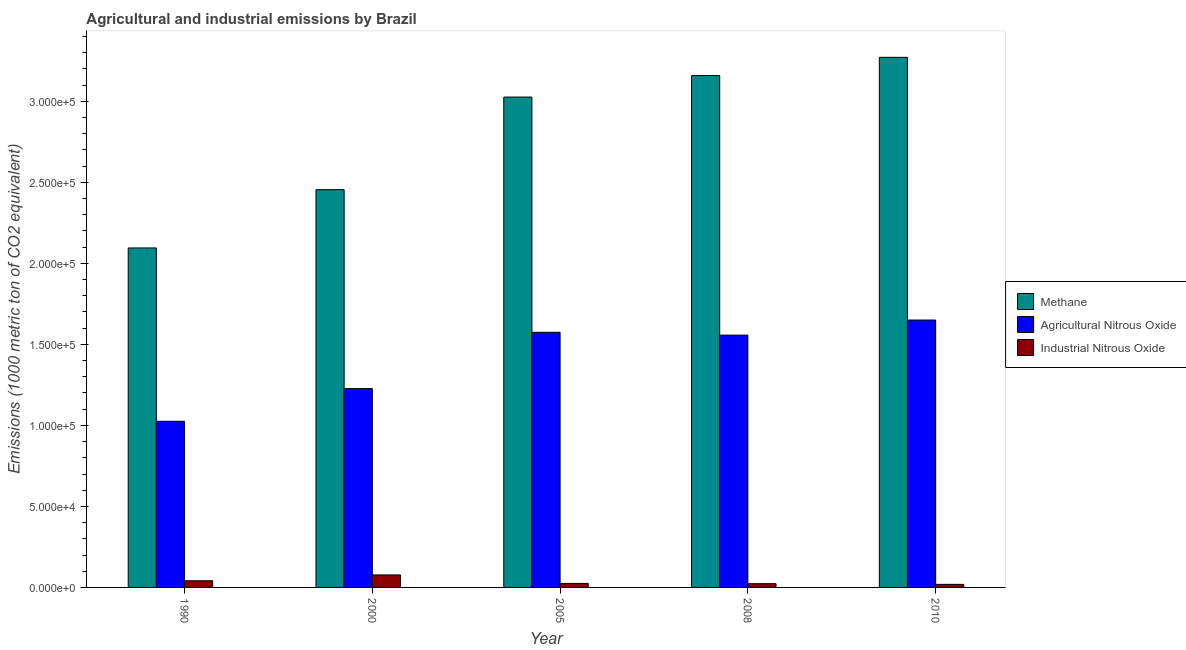How many groups of bars are there?
Your answer should be compact. 5. Are the number of bars per tick equal to the number of legend labels?
Your answer should be compact. Yes. Are the number of bars on each tick of the X-axis equal?
Provide a succinct answer. Yes. How many bars are there on the 1st tick from the right?
Offer a terse response. 3. What is the label of the 2nd group of bars from the left?
Offer a very short reply. 2000. What is the amount of agricultural nitrous oxide emissions in 2005?
Provide a succinct answer. 1.57e+05. Across all years, what is the maximum amount of methane emissions?
Your answer should be compact. 3.27e+05. Across all years, what is the minimum amount of agricultural nitrous oxide emissions?
Keep it short and to the point. 1.03e+05. In which year was the amount of agricultural nitrous oxide emissions maximum?
Keep it short and to the point. 2010. In which year was the amount of agricultural nitrous oxide emissions minimum?
Make the answer very short. 1990. What is the total amount of agricultural nitrous oxide emissions in the graph?
Provide a succinct answer. 7.03e+05. What is the difference between the amount of agricultural nitrous oxide emissions in 2005 and that in 2008?
Your response must be concise. 1744.8. What is the difference between the amount of industrial nitrous oxide emissions in 2005 and the amount of agricultural nitrous oxide emissions in 1990?
Keep it short and to the point. -1632.9. What is the average amount of agricultural nitrous oxide emissions per year?
Your answer should be compact. 1.41e+05. In how many years, is the amount of agricultural nitrous oxide emissions greater than 290000 metric ton?
Your response must be concise. 0. What is the ratio of the amount of industrial nitrous oxide emissions in 1990 to that in 2005?
Offer a terse response. 1.66. Is the amount of agricultural nitrous oxide emissions in 2005 less than that in 2010?
Offer a very short reply. Yes. What is the difference between the highest and the second highest amount of agricultural nitrous oxide emissions?
Provide a short and direct response. 7569.5. What is the difference between the highest and the lowest amount of methane emissions?
Provide a short and direct response. 1.18e+05. What does the 3rd bar from the left in 2005 represents?
Your response must be concise. Industrial Nitrous Oxide. What does the 2nd bar from the right in 2000 represents?
Provide a succinct answer. Agricultural Nitrous Oxide. How many years are there in the graph?
Make the answer very short. 5. Does the graph contain any zero values?
Keep it short and to the point. No. Does the graph contain grids?
Ensure brevity in your answer.  No. Where does the legend appear in the graph?
Keep it short and to the point. Center right. What is the title of the graph?
Provide a succinct answer. Agricultural and industrial emissions by Brazil. What is the label or title of the Y-axis?
Offer a terse response. Emissions (1000 metric ton of CO2 equivalent). What is the Emissions (1000 metric ton of CO2 equivalent) of Methane in 1990?
Provide a short and direct response. 2.10e+05. What is the Emissions (1000 metric ton of CO2 equivalent) in Agricultural Nitrous Oxide in 1990?
Offer a very short reply. 1.03e+05. What is the Emissions (1000 metric ton of CO2 equivalent) in Industrial Nitrous Oxide in 1990?
Your answer should be very brief. 4111.4. What is the Emissions (1000 metric ton of CO2 equivalent) of Methane in 2000?
Offer a very short reply. 2.45e+05. What is the Emissions (1000 metric ton of CO2 equivalent) of Agricultural Nitrous Oxide in 2000?
Make the answer very short. 1.23e+05. What is the Emissions (1000 metric ton of CO2 equivalent) in Industrial Nitrous Oxide in 2000?
Offer a terse response. 7709.7. What is the Emissions (1000 metric ton of CO2 equivalent) of Methane in 2005?
Keep it short and to the point. 3.03e+05. What is the Emissions (1000 metric ton of CO2 equivalent) of Agricultural Nitrous Oxide in 2005?
Your answer should be compact. 1.57e+05. What is the Emissions (1000 metric ton of CO2 equivalent) in Industrial Nitrous Oxide in 2005?
Give a very brief answer. 2478.5. What is the Emissions (1000 metric ton of CO2 equivalent) in Methane in 2008?
Ensure brevity in your answer.  3.16e+05. What is the Emissions (1000 metric ton of CO2 equivalent) in Agricultural Nitrous Oxide in 2008?
Provide a short and direct response. 1.56e+05. What is the Emissions (1000 metric ton of CO2 equivalent) of Industrial Nitrous Oxide in 2008?
Ensure brevity in your answer.  2306.2. What is the Emissions (1000 metric ton of CO2 equivalent) of Methane in 2010?
Provide a succinct answer. 3.27e+05. What is the Emissions (1000 metric ton of CO2 equivalent) of Agricultural Nitrous Oxide in 2010?
Offer a terse response. 1.65e+05. What is the Emissions (1000 metric ton of CO2 equivalent) in Industrial Nitrous Oxide in 2010?
Keep it short and to the point. 1890.3. Across all years, what is the maximum Emissions (1000 metric ton of CO2 equivalent) in Methane?
Offer a very short reply. 3.27e+05. Across all years, what is the maximum Emissions (1000 metric ton of CO2 equivalent) in Agricultural Nitrous Oxide?
Offer a very short reply. 1.65e+05. Across all years, what is the maximum Emissions (1000 metric ton of CO2 equivalent) of Industrial Nitrous Oxide?
Make the answer very short. 7709.7. Across all years, what is the minimum Emissions (1000 metric ton of CO2 equivalent) of Methane?
Keep it short and to the point. 2.10e+05. Across all years, what is the minimum Emissions (1000 metric ton of CO2 equivalent) of Agricultural Nitrous Oxide?
Keep it short and to the point. 1.03e+05. Across all years, what is the minimum Emissions (1000 metric ton of CO2 equivalent) of Industrial Nitrous Oxide?
Keep it short and to the point. 1890.3. What is the total Emissions (1000 metric ton of CO2 equivalent) of Methane in the graph?
Offer a very short reply. 1.40e+06. What is the total Emissions (1000 metric ton of CO2 equivalent) of Agricultural Nitrous Oxide in the graph?
Keep it short and to the point. 7.03e+05. What is the total Emissions (1000 metric ton of CO2 equivalent) of Industrial Nitrous Oxide in the graph?
Make the answer very short. 1.85e+04. What is the difference between the Emissions (1000 metric ton of CO2 equivalent) of Methane in 1990 and that in 2000?
Provide a succinct answer. -3.60e+04. What is the difference between the Emissions (1000 metric ton of CO2 equivalent) of Agricultural Nitrous Oxide in 1990 and that in 2000?
Provide a succinct answer. -2.02e+04. What is the difference between the Emissions (1000 metric ton of CO2 equivalent) of Industrial Nitrous Oxide in 1990 and that in 2000?
Provide a short and direct response. -3598.3. What is the difference between the Emissions (1000 metric ton of CO2 equivalent) of Methane in 1990 and that in 2005?
Your answer should be compact. -9.31e+04. What is the difference between the Emissions (1000 metric ton of CO2 equivalent) of Agricultural Nitrous Oxide in 1990 and that in 2005?
Keep it short and to the point. -5.49e+04. What is the difference between the Emissions (1000 metric ton of CO2 equivalent) of Industrial Nitrous Oxide in 1990 and that in 2005?
Make the answer very short. 1632.9. What is the difference between the Emissions (1000 metric ton of CO2 equivalent) of Methane in 1990 and that in 2008?
Make the answer very short. -1.06e+05. What is the difference between the Emissions (1000 metric ton of CO2 equivalent) in Agricultural Nitrous Oxide in 1990 and that in 2008?
Make the answer very short. -5.32e+04. What is the difference between the Emissions (1000 metric ton of CO2 equivalent) of Industrial Nitrous Oxide in 1990 and that in 2008?
Give a very brief answer. 1805.2. What is the difference between the Emissions (1000 metric ton of CO2 equivalent) of Methane in 1990 and that in 2010?
Your answer should be compact. -1.18e+05. What is the difference between the Emissions (1000 metric ton of CO2 equivalent) in Agricultural Nitrous Oxide in 1990 and that in 2010?
Ensure brevity in your answer.  -6.25e+04. What is the difference between the Emissions (1000 metric ton of CO2 equivalent) in Industrial Nitrous Oxide in 1990 and that in 2010?
Your response must be concise. 2221.1. What is the difference between the Emissions (1000 metric ton of CO2 equivalent) in Methane in 2000 and that in 2005?
Make the answer very short. -5.71e+04. What is the difference between the Emissions (1000 metric ton of CO2 equivalent) in Agricultural Nitrous Oxide in 2000 and that in 2005?
Your answer should be compact. -3.47e+04. What is the difference between the Emissions (1000 metric ton of CO2 equivalent) in Industrial Nitrous Oxide in 2000 and that in 2005?
Provide a succinct answer. 5231.2. What is the difference between the Emissions (1000 metric ton of CO2 equivalent) in Methane in 2000 and that in 2008?
Your answer should be very brief. -7.04e+04. What is the difference between the Emissions (1000 metric ton of CO2 equivalent) of Agricultural Nitrous Oxide in 2000 and that in 2008?
Provide a succinct answer. -3.30e+04. What is the difference between the Emissions (1000 metric ton of CO2 equivalent) of Industrial Nitrous Oxide in 2000 and that in 2008?
Give a very brief answer. 5403.5. What is the difference between the Emissions (1000 metric ton of CO2 equivalent) in Methane in 2000 and that in 2010?
Offer a very short reply. -8.17e+04. What is the difference between the Emissions (1000 metric ton of CO2 equivalent) of Agricultural Nitrous Oxide in 2000 and that in 2010?
Your response must be concise. -4.23e+04. What is the difference between the Emissions (1000 metric ton of CO2 equivalent) of Industrial Nitrous Oxide in 2000 and that in 2010?
Your response must be concise. 5819.4. What is the difference between the Emissions (1000 metric ton of CO2 equivalent) of Methane in 2005 and that in 2008?
Your answer should be compact. -1.33e+04. What is the difference between the Emissions (1000 metric ton of CO2 equivalent) of Agricultural Nitrous Oxide in 2005 and that in 2008?
Ensure brevity in your answer.  1744.8. What is the difference between the Emissions (1000 metric ton of CO2 equivalent) in Industrial Nitrous Oxide in 2005 and that in 2008?
Your answer should be very brief. 172.3. What is the difference between the Emissions (1000 metric ton of CO2 equivalent) of Methane in 2005 and that in 2010?
Make the answer very short. -2.45e+04. What is the difference between the Emissions (1000 metric ton of CO2 equivalent) of Agricultural Nitrous Oxide in 2005 and that in 2010?
Your answer should be very brief. -7569.5. What is the difference between the Emissions (1000 metric ton of CO2 equivalent) in Industrial Nitrous Oxide in 2005 and that in 2010?
Your answer should be very brief. 588.2. What is the difference between the Emissions (1000 metric ton of CO2 equivalent) in Methane in 2008 and that in 2010?
Give a very brief answer. -1.13e+04. What is the difference between the Emissions (1000 metric ton of CO2 equivalent) of Agricultural Nitrous Oxide in 2008 and that in 2010?
Offer a very short reply. -9314.3. What is the difference between the Emissions (1000 metric ton of CO2 equivalent) of Industrial Nitrous Oxide in 2008 and that in 2010?
Provide a short and direct response. 415.9. What is the difference between the Emissions (1000 metric ton of CO2 equivalent) in Methane in 1990 and the Emissions (1000 metric ton of CO2 equivalent) in Agricultural Nitrous Oxide in 2000?
Offer a terse response. 8.68e+04. What is the difference between the Emissions (1000 metric ton of CO2 equivalent) of Methane in 1990 and the Emissions (1000 metric ton of CO2 equivalent) of Industrial Nitrous Oxide in 2000?
Give a very brief answer. 2.02e+05. What is the difference between the Emissions (1000 metric ton of CO2 equivalent) in Agricultural Nitrous Oxide in 1990 and the Emissions (1000 metric ton of CO2 equivalent) in Industrial Nitrous Oxide in 2000?
Keep it short and to the point. 9.48e+04. What is the difference between the Emissions (1000 metric ton of CO2 equivalent) in Methane in 1990 and the Emissions (1000 metric ton of CO2 equivalent) in Agricultural Nitrous Oxide in 2005?
Offer a terse response. 5.21e+04. What is the difference between the Emissions (1000 metric ton of CO2 equivalent) of Methane in 1990 and the Emissions (1000 metric ton of CO2 equivalent) of Industrial Nitrous Oxide in 2005?
Offer a terse response. 2.07e+05. What is the difference between the Emissions (1000 metric ton of CO2 equivalent) in Agricultural Nitrous Oxide in 1990 and the Emissions (1000 metric ton of CO2 equivalent) in Industrial Nitrous Oxide in 2005?
Give a very brief answer. 1.00e+05. What is the difference between the Emissions (1000 metric ton of CO2 equivalent) of Methane in 1990 and the Emissions (1000 metric ton of CO2 equivalent) of Agricultural Nitrous Oxide in 2008?
Offer a terse response. 5.38e+04. What is the difference between the Emissions (1000 metric ton of CO2 equivalent) in Methane in 1990 and the Emissions (1000 metric ton of CO2 equivalent) in Industrial Nitrous Oxide in 2008?
Keep it short and to the point. 2.07e+05. What is the difference between the Emissions (1000 metric ton of CO2 equivalent) in Agricultural Nitrous Oxide in 1990 and the Emissions (1000 metric ton of CO2 equivalent) in Industrial Nitrous Oxide in 2008?
Offer a very short reply. 1.00e+05. What is the difference between the Emissions (1000 metric ton of CO2 equivalent) in Methane in 1990 and the Emissions (1000 metric ton of CO2 equivalent) in Agricultural Nitrous Oxide in 2010?
Provide a succinct answer. 4.45e+04. What is the difference between the Emissions (1000 metric ton of CO2 equivalent) of Methane in 1990 and the Emissions (1000 metric ton of CO2 equivalent) of Industrial Nitrous Oxide in 2010?
Make the answer very short. 2.08e+05. What is the difference between the Emissions (1000 metric ton of CO2 equivalent) of Agricultural Nitrous Oxide in 1990 and the Emissions (1000 metric ton of CO2 equivalent) of Industrial Nitrous Oxide in 2010?
Offer a terse response. 1.01e+05. What is the difference between the Emissions (1000 metric ton of CO2 equivalent) of Methane in 2000 and the Emissions (1000 metric ton of CO2 equivalent) of Agricultural Nitrous Oxide in 2005?
Ensure brevity in your answer.  8.80e+04. What is the difference between the Emissions (1000 metric ton of CO2 equivalent) of Methane in 2000 and the Emissions (1000 metric ton of CO2 equivalent) of Industrial Nitrous Oxide in 2005?
Your answer should be compact. 2.43e+05. What is the difference between the Emissions (1000 metric ton of CO2 equivalent) in Agricultural Nitrous Oxide in 2000 and the Emissions (1000 metric ton of CO2 equivalent) in Industrial Nitrous Oxide in 2005?
Provide a succinct answer. 1.20e+05. What is the difference between the Emissions (1000 metric ton of CO2 equivalent) in Methane in 2000 and the Emissions (1000 metric ton of CO2 equivalent) in Agricultural Nitrous Oxide in 2008?
Your response must be concise. 8.98e+04. What is the difference between the Emissions (1000 metric ton of CO2 equivalent) of Methane in 2000 and the Emissions (1000 metric ton of CO2 equivalent) of Industrial Nitrous Oxide in 2008?
Offer a terse response. 2.43e+05. What is the difference between the Emissions (1000 metric ton of CO2 equivalent) of Agricultural Nitrous Oxide in 2000 and the Emissions (1000 metric ton of CO2 equivalent) of Industrial Nitrous Oxide in 2008?
Your response must be concise. 1.20e+05. What is the difference between the Emissions (1000 metric ton of CO2 equivalent) in Methane in 2000 and the Emissions (1000 metric ton of CO2 equivalent) in Agricultural Nitrous Oxide in 2010?
Offer a very short reply. 8.05e+04. What is the difference between the Emissions (1000 metric ton of CO2 equivalent) of Methane in 2000 and the Emissions (1000 metric ton of CO2 equivalent) of Industrial Nitrous Oxide in 2010?
Your answer should be compact. 2.44e+05. What is the difference between the Emissions (1000 metric ton of CO2 equivalent) of Agricultural Nitrous Oxide in 2000 and the Emissions (1000 metric ton of CO2 equivalent) of Industrial Nitrous Oxide in 2010?
Provide a succinct answer. 1.21e+05. What is the difference between the Emissions (1000 metric ton of CO2 equivalent) in Methane in 2005 and the Emissions (1000 metric ton of CO2 equivalent) in Agricultural Nitrous Oxide in 2008?
Offer a terse response. 1.47e+05. What is the difference between the Emissions (1000 metric ton of CO2 equivalent) of Methane in 2005 and the Emissions (1000 metric ton of CO2 equivalent) of Industrial Nitrous Oxide in 2008?
Provide a succinct answer. 3.00e+05. What is the difference between the Emissions (1000 metric ton of CO2 equivalent) of Agricultural Nitrous Oxide in 2005 and the Emissions (1000 metric ton of CO2 equivalent) of Industrial Nitrous Oxide in 2008?
Offer a very short reply. 1.55e+05. What is the difference between the Emissions (1000 metric ton of CO2 equivalent) in Methane in 2005 and the Emissions (1000 metric ton of CO2 equivalent) in Agricultural Nitrous Oxide in 2010?
Provide a short and direct response. 1.38e+05. What is the difference between the Emissions (1000 metric ton of CO2 equivalent) in Methane in 2005 and the Emissions (1000 metric ton of CO2 equivalent) in Industrial Nitrous Oxide in 2010?
Give a very brief answer. 3.01e+05. What is the difference between the Emissions (1000 metric ton of CO2 equivalent) in Agricultural Nitrous Oxide in 2005 and the Emissions (1000 metric ton of CO2 equivalent) in Industrial Nitrous Oxide in 2010?
Provide a succinct answer. 1.56e+05. What is the difference between the Emissions (1000 metric ton of CO2 equivalent) in Methane in 2008 and the Emissions (1000 metric ton of CO2 equivalent) in Agricultural Nitrous Oxide in 2010?
Keep it short and to the point. 1.51e+05. What is the difference between the Emissions (1000 metric ton of CO2 equivalent) in Methane in 2008 and the Emissions (1000 metric ton of CO2 equivalent) in Industrial Nitrous Oxide in 2010?
Provide a short and direct response. 3.14e+05. What is the difference between the Emissions (1000 metric ton of CO2 equivalent) in Agricultural Nitrous Oxide in 2008 and the Emissions (1000 metric ton of CO2 equivalent) in Industrial Nitrous Oxide in 2010?
Keep it short and to the point. 1.54e+05. What is the average Emissions (1000 metric ton of CO2 equivalent) in Methane per year?
Your response must be concise. 2.80e+05. What is the average Emissions (1000 metric ton of CO2 equivalent) in Agricultural Nitrous Oxide per year?
Offer a very short reply. 1.41e+05. What is the average Emissions (1000 metric ton of CO2 equivalent) in Industrial Nitrous Oxide per year?
Make the answer very short. 3699.22. In the year 1990, what is the difference between the Emissions (1000 metric ton of CO2 equivalent) of Methane and Emissions (1000 metric ton of CO2 equivalent) of Agricultural Nitrous Oxide?
Keep it short and to the point. 1.07e+05. In the year 1990, what is the difference between the Emissions (1000 metric ton of CO2 equivalent) in Methane and Emissions (1000 metric ton of CO2 equivalent) in Industrial Nitrous Oxide?
Your response must be concise. 2.05e+05. In the year 1990, what is the difference between the Emissions (1000 metric ton of CO2 equivalent) in Agricultural Nitrous Oxide and Emissions (1000 metric ton of CO2 equivalent) in Industrial Nitrous Oxide?
Give a very brief answer. 9.84e+04. In the year 2000, what is the difference between the Emissions (1000 metric ton of CO2 equivalent) of Methane and Emissions (1000 metric ton of CO2 equivalent) of Agricultural Nitrous Oxide?
Make the answer very short. 1.23e+05. In the year 2000, what is the difference between the Emissions (1000 metric ton of CO2 equivalent) of Methane and Emissions (1000 metric ton of CO2 equivalent) of Industrial Nitrous Oxide?
Make the answer very short. 2.38e+05. In the year 2000, what is the difference between the Emissions (1000 metric ton of CO2 equivalent) of Agricultural Nitrous Oxide and Emissions (1000 metric ton of CO2 equivalent) of Industrial Nitrous Oxide?
Offer a very short reply. 1.15e+05. In the year 2005, what is the difference between the Emissions (1000 metric ton of CO2 equivalent) in Methane and Emissions (1000 metric ton of CO2 equivalent) in Agricultural Nitrous Oxide?
Give a very brief answer. 1.45e+05. In the year 2005, what is the difference between the Emissions (1000 metric ton of CO2 equivalent) in Methane and Emissions (1000 metric ton of CO2 equivalent) in Industrial Nitrous Oxide?
Keep it short and to the point. 3.00e+05. In the year 2005, what is the difference between the Emissions (1000 metric ton of CO2 equivalent) in Agricultural Nitrous Oxide and Emissions (1000 metric ton of CO2 equivalent) in Industrial Nitrous Oxide?
Make the answer very short. 1.55e+05. In the year 2008, what is the difference between the Emissions (1000 metric ton of CO2 equivalent) of Methane and Emissions (1000 metric ton of CO2 equivalent) of Agricultural Nitrous Oxide?
Give a very brief answer. 1.60e+05. In the year 2008, what is the difference between the Emissions (1000 metric ton of CO2 equivalent) of Methane and Emissions (1000 metric ton of CO2 equivalent) of Industrial Nitrous Oxide?
Your response must be concise. 3.14e+05. In the year 2008, what is the difference between the Emissions (1000 metric ton of CO2 equivalent) of Agricultural Nitrous Oxide and Emissions (1000 metric ton of CO2 equivalent) of Industrial Nitrous Oxide?
Keep it short and to the point. 1.53e+05. In the year 2010, what is the difference between the Emissions (1000 metric ton of CO2 equivalent) in Methane and Emissions (1000 metric ton of CO2 equivalent) in Agricultural Nitrous Oxide?
Offer a very short reply. 1.62e+05. In the year 2010, what is the difference between the Emissions (1000 metric ton of CO2 equivalent) of Methane and Emissions (1000 metric ton of CO2 equivalent) of Industrial Nitrous Oxide?
Your answer should be very brief. 3.25e+05. In the year 2010, what is the difference between the Emissions (1000 metric ton of CO2 equivalent) in Agricultural Nitrous Oxide and Emissions (1000 metric ton of CO2 equivalent) in Industrial Nitrous Oxide?
Make the answer very short. 1.63e+05. What is the ratio of the Emissions (1000 metric ton of CO2 equivalent) of Methane in 1990 to that in 2000?
Offer a terse response. 0.85. What is the ratio of the Emissions (1000 metric ton of CO2 equivalent) in Agricultural Nitrous Oxide in 1990 to that in 2000?
Offer a very short reply. 0.84. What is the ratio of the Emissions (1000 metric ton of CO2 equivalent) of Industrial Nitrous Oxide in 1990 to that in 2000?
Provide a short and direct response. 0.53. What is the ratio of the Emissions (1000 metric ton of CO2 equivalent) of Methane in 1990 to that in 2005?
Ensure brevity in your answer.  0.69. What is the ratio of the Emissions (1000 metric ton of CO2 equivalent) in Agricultural Nitrous Oxide in 1990 to that in 2005?
Provide a succinct answer. 0.65. What is the ratio of the Emissions (1000 metric ton of CO2 equivalent) of Industrial Nitrous Oxide in 1990 to that in 2005?
Your answer should be very brief. 1.66. What is the ratio of the Emissions (1000 metric ton of CO2 equivalent) of Methane in 1990 to that in 2008?
Make the answer very short. 0.66. What is the ratio of the Emissions (1000 metric ton of CO2 equivalent) in Agricultural Nitrous Oxide in 1990 to that in 2008?
Make the answer very short. 0.66. What is the ratio of the Emissions (1000 metric ton of CO2 equivalent) of Industrial Nitrous Oxide in 1990 to that in 2008?
Offer a very short reply. 1.78. What is the ratio of the Emissions (1000 metric ton of CO2 equivalent) of Methane in 1990 to that in 2010?
Ensure brevity in your answer.  0.64. What is the ratio of the Emissions (1000 metric ton of CO2 equivalent) in Agricultural Nitrous Oxide in 1990 to that in 2010?
Your answer should be very brief. 0.62. What is the ratio of the Emissions (1000 metric ton of CO2 equivalent) in Industrial Nitrous Oxide in 1990 to that in 2010?
Ensure brevity in your answer.  2.17. What is the ratio of the Emissions (1000 metric ton of CO2 equivalent) in Methane in 2000 to that in 2005?
Provide a short and direct response. 0.81. What is the ratio of the Emissions (1000 metric ton of CO2 equivalent) in Agricultural Nitrous Oxide in 2000 to that in 2005?
Your response must be concise. 0.78. What is the ratio of the Emissions (1000 metric ton of CO2 equivalent) of Industrial Nitrous Oxide in 2000 to that in 2005?
Offer a terse response. 3.11. What is the ratio of the Emissions (1000 metric ton of CO2 equivalent) in Methane in 2000 to that in 2008?
Provide a succinct answer. 0.78. What is the ratio of the Emissions (1000 metric ton of CO2 equivalent) in Agricultural Nitrous Oxide in 2000 to that in 2008?
Offer a terse response. 0.79. What is the ratio of the Emissions (1000 metric ton of CO2 equivalent) of Industrial Nitrous Oxide in 2000 to that in 2008?
Your answer should be very brief. 3.34. What is the ratio of the Emissions (1000 metric ton of CO2 equivalent) in Methane in 2000 to that in 2010?
Provide a succinct answer. 0.75. What is the ratio of the Emissions (1000 metric ton of CO2 equivalent) in Agricultural Nitrous Oxide in 2000 to that in 2010?
Keep it short and to the point. 0.74. What is the ratio of the Emissions (1000 metric ton of CO2 equivalent) in Industrial Nitrous Oxide in 2000 to that in 2010?
Offer a very short reply. 4.08. What is the ratio of the Emissions (1000 metric ton of CO2 equivalent) in Methane in 2005 to that in 2008?
Provide a short and direct response. 0.96. What is the ratio of the Emissions (1000 metric ton of CO2 equivalent) of Agricultural Nitrous Oxide in 2005 to that in 2008?
Provide a succinct answer. 1.01. What is the ratio of the Emissions (1000 metric ton of CO2 equivalent) in Industrial Nitrous Oxide in 2005 to that in 2008?
Your answer should be very brief. 1.07. What is the ratio of the Emissions (1000 metric ton of CO2 equivalent) in Methane in 2005 to that in 2010?
Offer a terse response. 0.93. What is the ratio of the Emissions (1000 metric ton of CO2 equivalent) in Agricultural Nitrous Oxide in 2005 to that in 2010?
Keep it short and to the point. 0.95. What is the ratio of the Emissions (1000 metric ton of CO2 equivalent) of Industrial Nitrous Oxide in 2005 to that in 2010?
Your answer should be compact. 1.31. What is the ratio of the Emissions (1000 metric ton of CO2 equivalent) of Methane in 2008 to that in 2010?
Make the answer very short. 0.97. What is the ratio of the Emissions (1000 metric ton of CO2 equivalent) of Agricultural Nitrous Oxide in 2008 to that in 2010?
Give a very brief answer. 0.94. What is the ratio of the Emissions (1000 metric ton of CO2 equivalent) of Industrial Nitrous Oxide in 2008 to that in 2010?
Provide a succinct answer. 1.22. What is the difference between the highest and the second highest Emissions (1000 metric ton of CO2 equivalent) of Methane?
Offer a very short reply. 1.13e+04. What is the difference between the highest and the second highest Emissions (1000 metric ton of CO2 equivalent) of Agricultural Nitrous Oxide?
Make the answer very short. 7569.5. What is the difference between the highest and the second highest Emissions (1000 metric ton of CO2 equivalent) in Industrial Nitrous Oxide?
Ensure brevity in your answer.  3598.3. What is the difference between the highest and the lowest Emissions (1000 metric ton of CO2 equivalent) of Methane?
Offer a terse response. 1.18e+05. What is the difference between the highest and the lowest Emissions (1000 metric ton of CO2 equivalent) of Agricultural Nitrous Oxide?
Provide a succinct answer. 6.25e+04. What is the difference between the highest and the lowest Emissions (1000 metric ton of CO2 equivalent) of Industrial Nitrous Oxide?
Offer a terse response. 5819.4. 